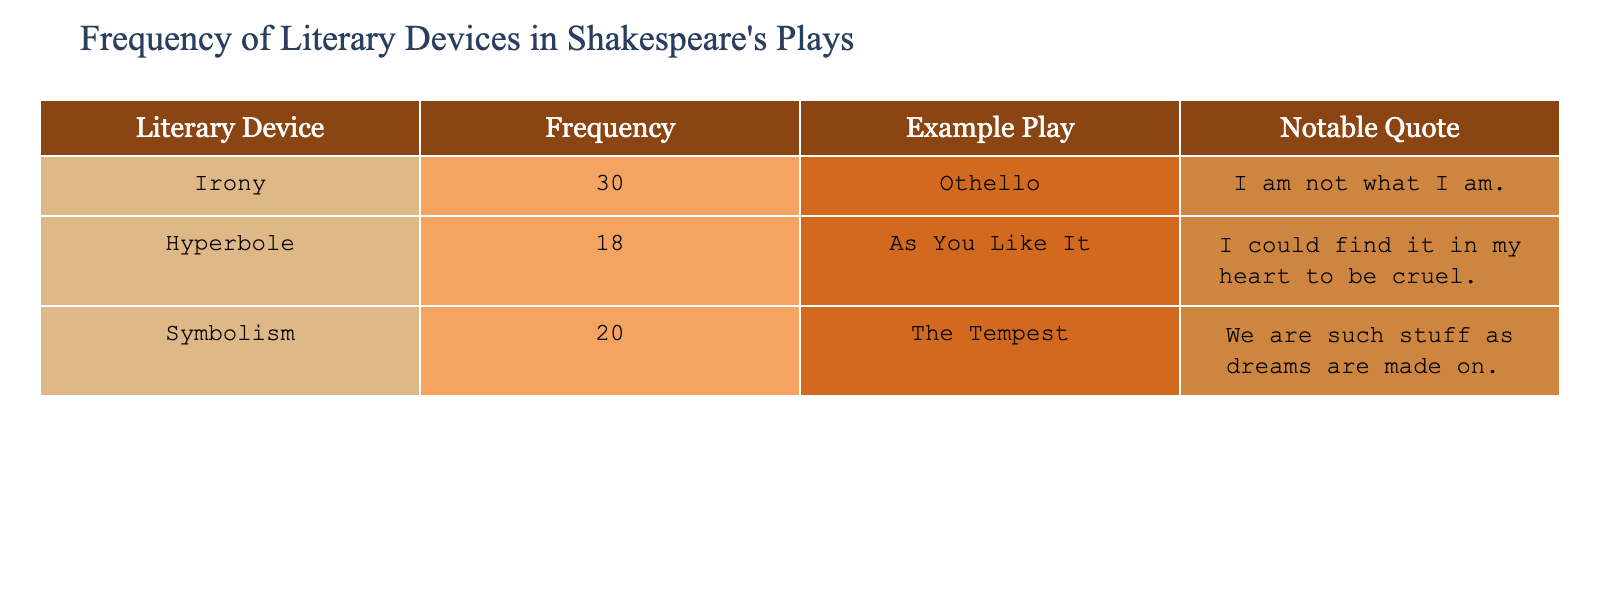What is the frequency of irony in Shakespeare's plays? According to the table, the frequency of irony is directly listed as 30.
Answer: 30 Which play contains a notable quote that uses hyperbole? The table shows that "As You Like It" contains a notable quote related to hyperbole.
Answer: As You Like It Is symbolism used more frequently than hyperbole in Shakespeare's plays? The table lists the frequency of symbolism as 20 and hyperbole as 18. Since 20 is greater than 18, symbolism is indeed used more frequently.
Answer: Yes What is the total frequency of literary devices listed in the table? To find the total frequency, add the frequencies of all the literary devices: 30 (irony) + 18 (hyperbole) + 20 (symbolism) = 68.
Answer: 68 Which literary device has the least frequency in Shakespeare's plays? The frequencies listed are: irony (30), hyperbole (18), and symbolism (20). The lowest frequency is associated with hyperbole, which is 18.
Answer: Hyperbole Is there a notable quote for each literary device in the table? The table presents a notable quote for irony, hyperbole, and symbolism, confirming that there is indeed a notable quote for each literary device listed.
Answer: Yes What is the difference in frequency between irony and symbolism? The frequency of irony is 30 and symbolism is 20. The difference is calculated as 30 - 20 = 10.
Answer: 10 Which literary device is associated with the quote "I am not what I am."? The table indicates that the quote "I am not what I am." is associated with irony, as shown in the relevant entry.
Answer: Irony How many more times is irony used than symbolism? Irony is used 30 times while symbolism is used 20 times. Thus, the difference is 30 - 20 = 10, meaning irony is used 10 more times.
Answer: 10 